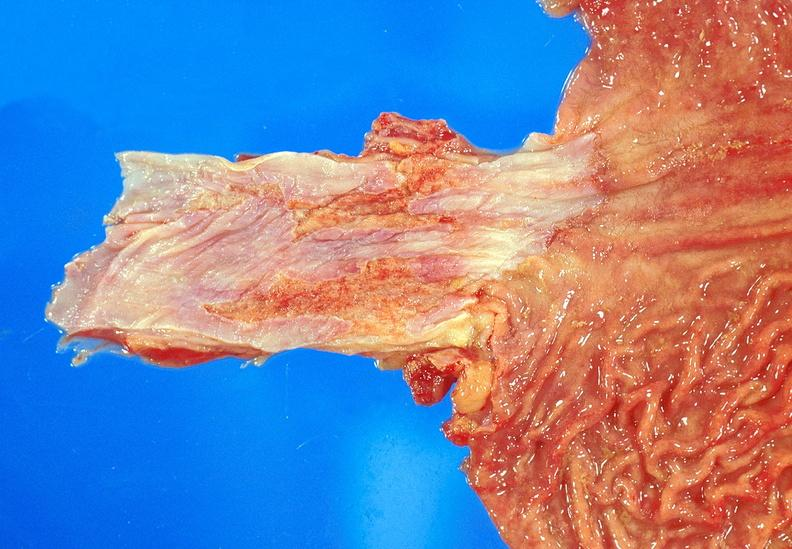where does this belong to?
Answer the question using a single word or phrase. Gastrointestinal system 